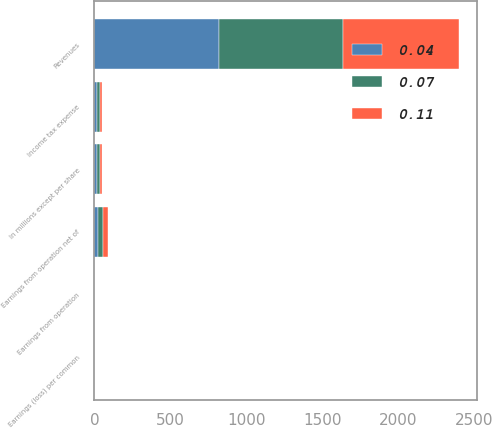Convert chart. <chart><loc_0><loc_0><loc_500><loc_500><stacked_bar_chart><ecel><fcel>In millions except per share<fcel>Revenues<fcel>Income tax expense<fcel>Earnings from operation net of<fcel>Earnings from operation<fcel>Earnings (loss) per common<nl><fcel>0.07<fcel>17<fcel>816<fcel>16<fcel>36<fcel>0.07<fcel>0.11<nl><fcel>0.04<fcel>17<fcel>820<fcel>18<fcel>22<fcel>0.04<fcel>0.04<nl><fcel>0.11<fcel>17<fcel>763<fcel>17<fcel>34<fcel>0.07<fcel>0.07<nl></chart> 